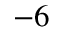Convert formula to latex. <formula><loc_0><loc_0><loc_500><loc_500>^ { - 6 }</formula> 